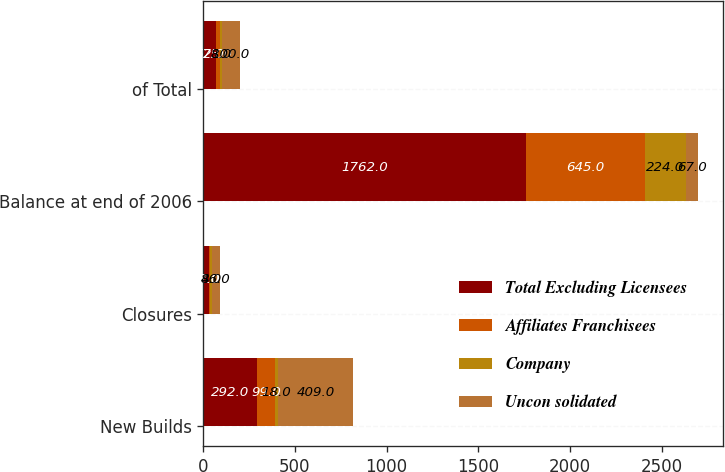Convert chart. <chart><loc_0><loc_0><loc_500><loc_500><stacked_bar_chart><ecel><fcel>New Builds<fcel>Closures<fcel>Balance at end of 2006<fcel>of Total<nl><fcel>Total Excluding Licensees<fcel>292<fcel>31<fcel>1762<fcel>67<nl><fcel>Affiliates Franchisees<fcel>99<fcel>7<fcel>645<fcel>25<nl><fcel>Company<fcel>18<fcel>8<fcel>224<fcel>8<nl><fcel>Uncon solidated<fcel>409<fcel>46<fcel>67<fcel>100<nl></chart> 